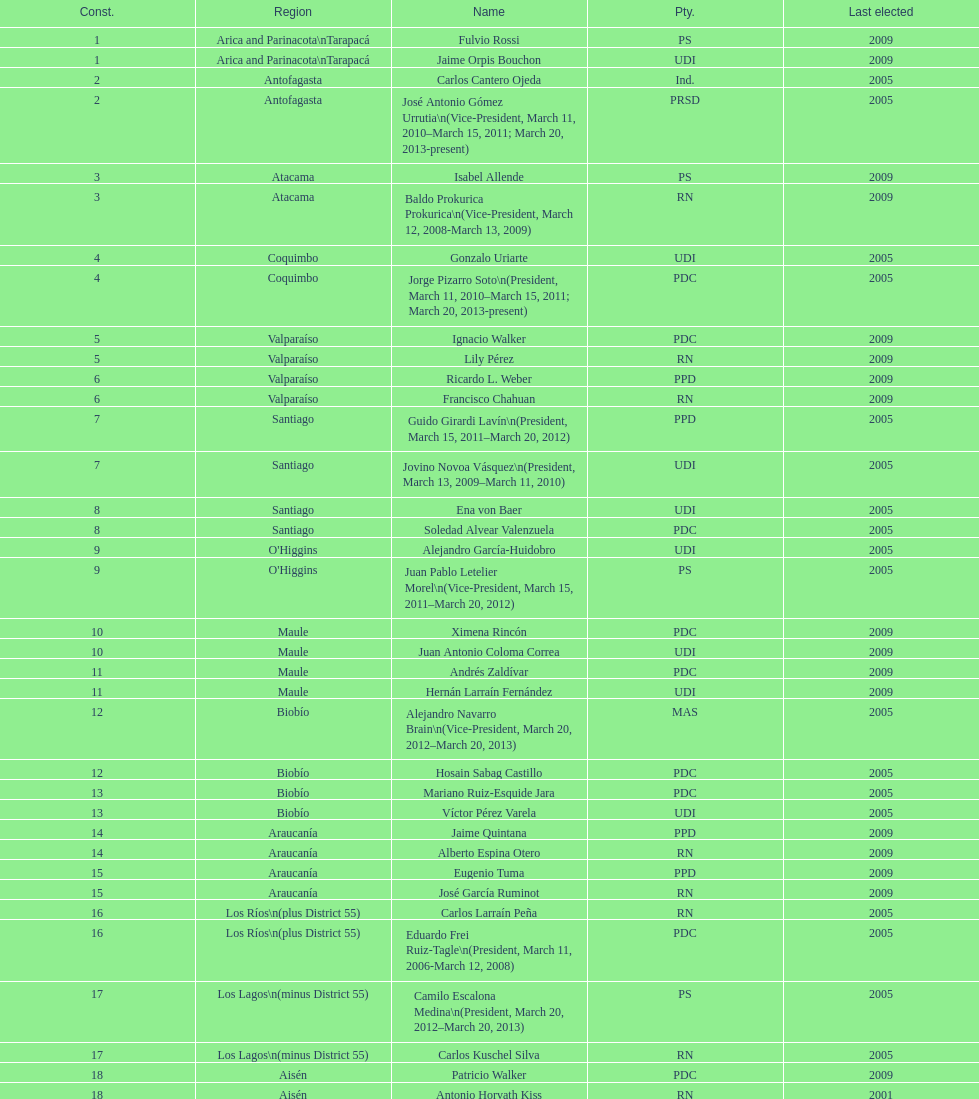Which party did jaime quintana belong to? PPD. 